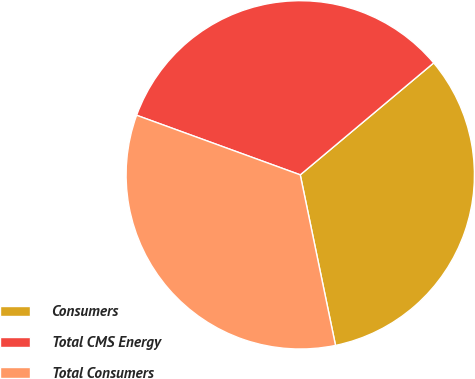Convert chart to OTSL. <chart><loc_0><loc_0><loc_500><loc_500><pie_chart><fcel>Consumers<fcel>Total CMS Energy<fcel>Total Consumers<nl><fcel>32.86%<fcel>33.33%<fcel>33.8%<nl></chart> 